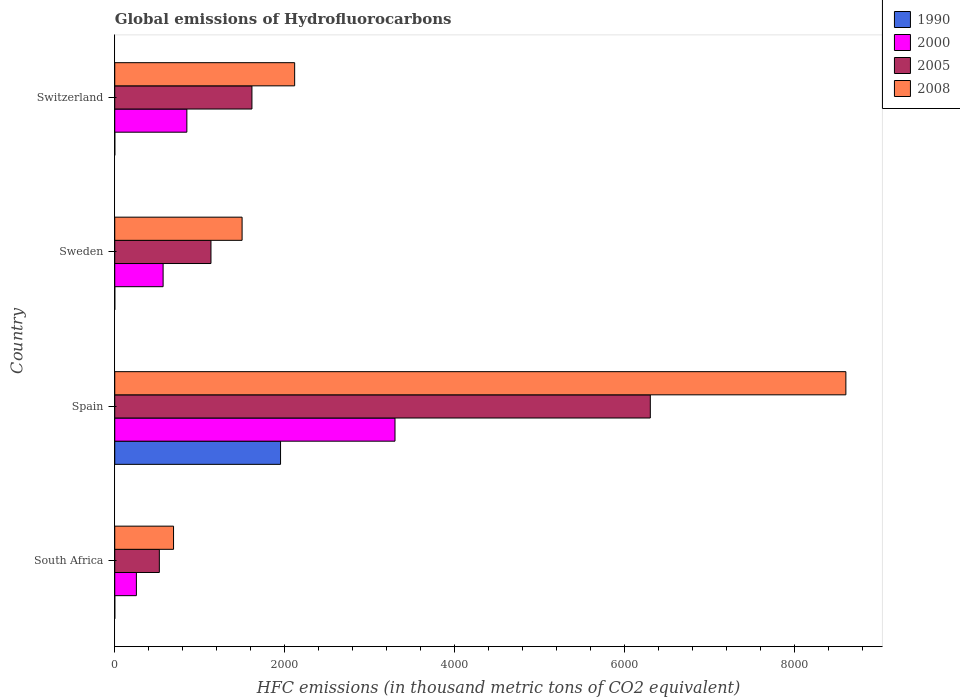Are the number of bars on each tick of the Y-axis equal?
Keep it short and to the point. Yes. How many bars are there on the 2nd tick from the bottom?
Keep it short and to the point. 4. What is the label of the 2nd group of bars from the top?
Make the answer very short. Sweden. In how many cases, is the number of bars for a given country not equal to the number of legend labels?
Offer a terse response. 0. What is the global emissions of Hydrofluorocarbons in 2000 in Spain?
Provide a short and direct response. 3296.8. Across all countries, what is the maximum global emissions of Hydrofluorocarbons in 2000?
Provide a short and direct response. 3296.8. Across all countries, what is the minimum global emissions of Hydrofluorocarbons in 2008?
Your answer should be very brief. 691.6. In which country was the global emissions of Hydrofluorocarbons in 2000 minimum?
Your answer should be very brief. South Africa. What is the total global emissions of Hydrofluorocarbons in 1990 in the graph?
Provide a succinct answer. 1951. What is the difference between the global emissions of Hydrofluorocarbons in 2000 in Spain and that in Sweden?
Make the answer very short. 2728. What is the difference between the global emissions of Hydrofluorocarbons in 2005 in Switzerland and the global emissions of Hydrofluorocarbons in 1990 in Spain?
Keep it short and to the point. -336.5. What is the average global emissions of Hydrofluorocarbons in 1990 per country?
Make the answer very short. 487.75. What is the difference between the global emissions of Hydrofluorocarbons in 2008 and global emissions of Hydrofluorocarbons in 1990 in Spain?
Provide a succinct answer. 6650.6. In how many countries, is the global emissions of Hydrofluorocarbons in 1990 greater than 2000 thousand metric tons?
Ensure brevity in your answer.  0. What is the ratio of the global emissions of Hydrofluorocarbons in 2008 in Spain to that in Sweden?
Give a very brief answer. 5.74. Is the global emissions of Hydrofluorocarbons in 2000 in Spain less than that in Sweden?
Provide a short and direct response. No. Is the difference between the global emissions of Hydrofluorocarbons in 2008 in Spain and Switzerland greater than the difference between the global emissions of Hydrofluorocarbons in 1990 in Spain and Switzerland?
Your answer should be very brief. Yes. What is the difference between the highest and the second highest global emissions of Hydrofluorocarbons in 2000?
Give a very brief answer. 2448.6. What is the difference between the highest and the lowest global emissions of Hydrofluorocarbons in 2000?
Ensure brevity in your answer.  3042.2. Is the sum of the global emissions of Hydrofluorocarbons in 2008 in South Africa and Spain greater than the maximum global emissions of Hydrofluorocarbons in 1990 across all countries?
Offer a very short reply. Yes. Is it the case that in every country, the sum of the global emissions of Hydrofluorocarbons in 2000 and global emissions of Hydrofluorocarbons in 1990 is greater than the sum of global emissions of Hydrofluorocarbons in 2005 and global emissions of Hydrofluorocarbons in 2008?
Ensure brevity in your answer.  No. What does the 1st bar from the bottom in Sweden represents?
Your answer should be compact. 1990. Is it the case that in every country, the sum of the global emissions of Hydrofluorocarbons in 1990 and global emissions of Hydrofluorocarbons in 2008 is greater than the global emissions of Hydrofluorocarbons in 2005?
Keep it short and to the point. Yes. What is the difference between two consecutive major ticks on the X-axis?
Ensure brevity in your answer.  2000. Does the graph contain any zero values?
Keep it short and to the point. No. Does the graph contain grids?
Your answer should be compact. No. How many legend labels are there?
Your response must be concise. 4. How are the legend labels stacked?
Your response must be concise. Vertical. What is the title of the graph?
Offer a terse response. Global emissions of Hydrofluorocarbons. What is the label or title of the X-axis?
Make the answer very short. HFC emissions (in thousand metric tons of CO2 equivalent). What is the HFC emissions (in thousand metric tons of CO2 equivalent) in 2000 in South Africa?
Provide a succinct answer. 254.6. What is the HFC emissions (in thousand metric tons of CO2 equivalent) of 2005 in South Africa?
Offer a very short reply. 524.5. What is the HFC emissions (in thousand metric tons of CO2 equivalent) in 2008 in South Africa?
Provide a short and direct response. 691.6. What is the HFC emissions (in thousand metric tons of CO2 equivalent) of 1990 in Spain?
Give a very brief answer. 1950.3. What is the HFC emissions (in thousand metric tons of CO2 equivalent) of 2000 in Spain?
Provide a succinct answer. 3296.8. What is the HFC emissions (in thousand metric tons of CO2 equivalent) in 2005 in Spain?
Provide a short and direct response. 6300.3. What is the HFC emissions (in thousand metric tons of CO2 equivalent) in 2008 in Spain?
Ensure brevity in your answer.  8600.9. What is the HFC emissions (in thousand metric tons of CO2 equivalent) of 1990 in Sweden?
Your response must be concise. 0.2. What is the HFC emissions (in thousand metric tons of CO2 equivalent) of 2000 in Sweden?
Give a very brief answer. 568.8. What is the HFC emissions (in thousand metric tons of CO2 equivalent) of 2005 in Sweden?
Your answer should be compact. 1131.9. What is the HFC emissions (in thousand metric tons of CO2 equivalent) in 2008 in Sweden?
Your answer should be very brief. 1498. What is the HFC emissions (in thousand metric tons of CO2 equivalent) of 2000 in Switzerland?
Ensure brevity in your answer.  848.2. What is the HFC emissions (in thousand metric tons of CO2 equivalent) in 2005 in Switzerland?
Your response must be concise. 1613.8. What is the HFC emissions (in thousand metric tons of CO2 equivalent) in 2008 in Switzerland?
Keep it short and to the point. 2116.4. Across all countries, what is the maximum HFC emissions (in thousand metric tons of CO2 equivalent) in 1990?
Your answer should be very brief. 1950.3. Across all countries, what is the maximum HFC emissions (in thousand metric tons of CO2 equivalent) of 2000?
Provide a succinct answer. 3296.8. Across all countries, what is the maximum HFC emissions (in thousand metric tons of CO2 equivalent) of 2005?
Give a very brief answer. 6300.3. Across all countries, what is the maximum HFC emissions (in thousand metric tons of CO2 equivalent) in 2008?
Your answer should be very brief. 8600.9. Across all countries, what is the minimum HFC emissions (in thousand metric tons of CO2 equivalent) of 1990?
Make the answer very short. 0.2. Across all countries, what is the minimum HFC emissions (in thousand metric tons of CO2 equivalent) in 2000?
Offer a very short reply. 254.6. Across all countries, what is the minimum HFC emissions (in thousand metric tons of CO2 equivalent) in 2005?
Offer a terse response. 524.5. Across all countries, what is the minimum HFC emissions (in thousand metric tons of CO2 equivalent) in 2008?
Your answer should be compact. 691.6. What is the total HFC emissions (in thousand metric tons of CO2 equivalent) in 1990 in the graph?
Provide a short and direct response. 1951. What is the total HFC emissions (in thousand metric tons of CO2 equivalent) in 2000 in the graph?
Your answer should be compact. 4968.4. What is the total HFC emissions (in thousand metric tons of CO2 equivalent) in 2005 in the graph?
Provide a short and direct response. 9570.5. What is the total HFC emissions (in thousand metric tons of CO2 equivalent) of 2008 in the graph?
Your response must be concise. 1.29e+04. What is the difference between the HFC emissions (in thousand metric tons of CO2 equivalent) of 1990 in South Africa and that in Spain?
Give a very brief answer. -1950.1. What is the difference between the HFC emissions (in thousand metric tons of CO2 equivalent) in 2000 in South Africa and that in Spain?
Your answer should be compact. -3042.2. What is the difference between the HFC emissions (in thousand metric tons of CO2 equivalent) in 2005 in South Africa and that in Spain?
Offer a terse response. -5775.8. What is the difference between the HFC emissions (in thousand metric tons of CO2 equivalent) of 2008 in South Africa and that in Spain?
Give a very brief answer. -7909.3. What is the difference between the HFC emissions (in thousand metric tons of CO2 equivalent) of 2000 in South Africa and that in Sweden?
Offer a terse response. -314.2. What is the difference between the HFC emissions (in thousand metric tons of CO2 equivalent) in 2005 in South Africa and that in Sweden?
Make the answer very short. -607.4. What is the difference between the HFC emissions (in thousand metric tons of CO2 equivalent) in 2008 in South Africa and that in Sweden?
Your answer should be very brief. -806.4. What is the difference between the HFC emissions (in thousand metric tons of CO2 equivalent) of 1990 in South Africa and that in Switzerland?
Offer a terse response. -0.1. What is the difference between the HFC emissions (in thousand metric tons of CO2 equivalent) in 2000 in South Africa and that in Switzerland?
Make the answer very short. -593.6. What is the difference between the HFC emissions (in thousand metric tons of CO2 equivalent) of 2005 in South Africa and that in Switzerland?
Your answer should be very brief. -1089.3. What is the difference between the HFC emissions (in thousand metric tons of CO2 equivalent) of 2008 in South Africa and that in Switzerland?
Your response must be concise. -1424.8. What is the difference between the HFC emissions (in thousand metric tons of CO2 equivalent) in 1990 in Spain and that in Sweden?
Ensure brevity in your answer.  1950.1. What is the difference between the HFC emissions (in thousand metric tons of CO2 equivalent) in 2000 in Spain and that in Sweden?
Offer a very short reply. 2728. What is the difference between the HFC emissions (in thousand metric tons of CO2 equivalent) in 2005 in Spain and that in Sweden?
Your answer should be very brief. 5168.4. What is the difference between the HFC emissions (in thousand metric tons of CO2 equivalent) in 2008 in Spain and that in Sweden?
Give a very brief answer. 7102.9. What is the difference between the HFC emissions (in thousand metric tons of CO2 equivalent) in 1990 in Spain and that in Switzerland?
Provide a short and direct response. 1950. What is the difference between the HFC emissions (in thousand metric tons of CO2 equivalent) in 2000 in Spain and that in Switzerland?
Ensure brevity in your answer.  2448.6. What is the difference between the HFC emissions (in thousand metric tons of CO2 equivalent) of 2005 in Spain and that in Switzerland?
Your response must be concise. 4686.5. What is the difference between the HFC emissions (in thousand metric tons of CO2 equivalent) in 2008 in Spain and that in Switzerland?
Keep it short and to the point. 6484.5. What is the difference between the HFC emissions (in thousand metric tons of CO2 equivalent) in 1990 in Sweden and that in Switzerland?
Offer a very short reply. -0.1. What is the difference between the HFC emissions (in thousand metric tons of CO2 equivalent) in 2000 in Sweden and that in Switzerland?
Provide a succinct answer. -279.4. What is the difference between the HFC emissions (in thousand metric tons of CO2 equivalent) in 2005 in Sweden and that in Switzerland?
Give a very brief answer. -481.9. What is the difference between the HFC emissions (in thousand metric tons of CO2 equivalent) of 2008 in Sweden and that in Switzerland?
Offer a very short reply. -618.4. What is the difference between the HFC emissions (in thousand metric tons of CO2 equivalent) in 1990 in South Africa and the HFC emissions (in thousand metric tons of CO2 equivalent) in 2000 in Spain?
Provide a succinct answer. -3296.6. What is the difference between the HFC emissions (in thousand metric tons of CO2 equivalent) in 1990 in South Africa and the HFC emissions (in thousand metric tons of CO2 equivalent) in 2005 in Spain?
Provide a short and direct response. -6300.1. What is the difference between the HFC emissions (in thousand metric tons of CO2 equivalent) in 1990 in South Africa and the HFC emissions (in thousand metric tons of CO2 equivalent) in 2008 in Spain?
Your answer should be very brief. -8600.7. What is the difference between the HFC emissions (in thousand metric tons of CO2 equivalent) of 2000 in South Africa and the HFC emissions (in thousand metric tons of CO2 equivalent) of 2005 in Spain?
Offer a terse response. -6045.7. What is the difference between the HFC emissions (in thousand metric tons of CO2 equivalent) of 2000 in South Africa and the HFC emissions (in thousand metric tons of CO2 equivalent) of 2008 in Spain?
Offer a terse response. -8346.3. What is the difference between the HFC emissions (in thousand metric tons of CO2 equivalent) in 2005 in South Africa and the HFC emissions (in thousand metric tons of CO2 equivalent) in 2008 in Spain?
Ensure brevity in your answer.  -8076.4. What is the difference between the HFC emissions (in thousand metric tons of CO2 equivalent) of 1990 in South Africa and the HFC emissions (in thousand metric tons of CO2 equivalent) of 2000 in Sweden?
Provide a succinct answer. -568.6. What is the difference between the HFC emissions (in thousand metric tons of CO2 equivalent) of 1990 in South Africa and the HFC emissions (in thousand metric tons of CO2 equivalent) of 2005 in Sweden?
Give a very brief answer. -1131.7. What is the difference between the HFC emissions (in thousand metric tons of CO2 equivalent) in 1990 in South Africa and the HFC emissions (in thousand metric tons of CO2 equivalent) in 2008 in Sweden?
Keep it short and to the point. -1497.8. What is the difference between the HFC emissions (in thousand metric tons of CO2 equivalent) in 2000 in South Africa and the HFC emissions (in thousand metric tons of CO2 equivalent) in 2005 in Sweden?
Your response must be concise. -877.3. What is the difference between the HFC emissions (in thousand metric tons of CO2 equivalent) of 2000 in South Africa and the HFC emissions (in thousand metric tons of CO2 equivalent) of 2008 in Sweden?
Ensure brevity in your answer.  -1243.4. What is the difference between the HFC emissions (in thousand metric tons of CO2 equivalent) in 2005 in South Africa and the HFC emissions (in thousand metric tons of CO2 equivalent) in 2008 in Sweden?
Your response must be concise. -973.5. What is the difference between the HFC emissions (in thousand metric tons of CO2 equivalent) of 1990 in South Africa and the HFC emissions (in thousand metric tons of CO2 equivalent) of 2000 in Switzerland?
Provide a short and direct response. -848. What is the difference between the HFC emissions (in thousand metric tons of CO2 equivalent) of 1990 in South Africa and the HFC emissions (in thousand metric tons of CO2 equivalent) of 2005 in Switzerland?
Your answer should be compact. -1613.6. What is the difference between the HFC emissions (in thousand metric tons of CO2 equivalent) of 1990 in South Africa and the HFC emissions (in thousand metric tons of CO2 equivalent) of 2008 in Switzerland?
Your answer should be compact. -2116.2. What is the difference between the HFC emissions (in thousand metric tons of CO2 equivalent) in 2000 in South Africa and the HFC emissions (in thousand metric tons of CO2 equivalent) in 2005 in Switzerland?
Offer a very short reply. -1359.2. What is the difference between the HFC emissions (in thousand metric tons of CO2 equivalent) in 2000 in South Africa and the HFC emissions (in thousand metric tons of CO2 equivalent) in 2008 in Switzerland?
Offer a terse response. -1861.8. What is the difference between the HFC emissions (in thousand metric tons of CO2 equivalent) in 2005 in South Africa and the HFC emissions (in thousand metric tons of CO2 equivalent) in 2008 in Switzerland?
Your response must be concise. -1591.9. What is the difference between the HFC emissions (in thousand metric tons of CO2 equivalent) of 1990 in Spain and the HFC emissions (in thousand metric tons of CO2 equivalent) of 2000 in Sweden?
Keep it short and to the point. 1381.5. What is the difference between the HFC emissions (in thousand metric tons of CO2 equivalent) of 1990 in Spain and the HFC emissions (in thousand metric tons of CO2 equivalent) of 2005 in Sweden?
Make the answer very short. 818.4. What is the difference between the HFC emissions (in thousand metric tons of CO2 equivalent) in 1990 in Spain and the HFC emissions (in thousand metric tons of CO2 equivalent) in 2008 in Sweden?
Offer a terse response. 452.3. What is the difference between the HFC emissions (in thousand metric tons of CO2 equivalent) in 2000 in Spain and the HFC emissions (in thousand metric tons of CO2 equivalent) in 2005 in Sweden?
Offer a terse response. 2164.9. What is the difference between the HFC emissions (in thousand metric tons of CO2 equivalent) in 2000 in Spain and the HFC emissions (in thousand metric tons of CO2 equivalent) in 2008 in Sweden?
Make the answer very short. 1798.8. What is the difference between the HFC emissions (in thousand metric tons of CO2 equivalent) in 2005 in Spain and the HFC emissions (in thousand metric tons of CO2 equivalent) in 2008 in Sweden?
Provide a short and direct response. 4802.3. What is the difference between the HFC emissions (in thousand metric tons of CO2 equivalent) of 1990 in Spain and the HFC emissions (in thousand metric tons of CO2 equivalent) of 2000 in Switzerland?
Give a very brief answer. 1102.1. What is the difference between the HFC emissions (in thousand metric tons of CO2 equivalent) in 1990 in Spain and the HFC emissions (in thousand metric tons of CO2 equivalent) in 2005 in Switzerland?
Provide a short and direct response. 336.5. What is the difference between the HFC emissions (in thousand metric tons of CO2 equivalent) of 1990 in Spain and the HFC emissions (in thousand metric tons of CO2 equivalent) of 2008 in Switzerland?
Provide a short and direct response. -166.1. What is the difference between the HFC emissions (in thousand metric tons of CO2 equivalent) of 2000 in Spain and the HFC emissions (in thousand metric tons of CO2 equivalent) of 2005 in Switzerland?
Offer a terse response. 1683. What is the difference between the HFC emissions (in thousand metric tons of CO2 equivalent) of 2000 in Spain and the HFC emissions (in thousand metric tons of CO2 equivalent) of 2008 in Switzerland?
Provide a short and direct response. 1180.4. What is the difference between the HFC emissions (in thousand metric tons of CO2 equivalent) of 2005 in Spain and the HFC emissions (in thousand metric tons of CO2 equivalent) of 2008 in Switzerland?
Offer a very short reply. 4183.9. What is the difference between the HFC emissions (in thousand metric tons of CO2 equivalent) in 1990 in Sweden and the HFC emissions (in thousand metric tons of CO2 equivalent) in 2000 in Switzerland?
Provide a succinct answer. -848. What is the difference between the HFC emissions (in thousand metric tons of CO2 equivalent) in 1990 in Sweden and the HFC emissions (in thousand metric tons of CO2 equivalent) in 2005 in Switzerland?
Offer a terse response. -1613.6. What is the difference between the HFC emissions (in thousand metric tons of CO2 equivalent) of 1990 in Sweden and the HFC emissions (in thousand metric tons of CO2 equivalent) of 2008 in Switzerland?
Give a very brief answer. -2116.2. What is the difference between the HFC emissions (in thousand metric tons of CO2 equivalent) in 2000 in Sweden and the HFC emissions (in thousand metric tons of CO2 equivalent) in 2005 in Switzerland?
Give a very brief answer. -1045. What is the difference between the HFC emissions (in thousand metric tons of CO2 equivalent) of 2000 in Sweden and the HFC emissions (in thousand metric tons of CO2 equivalent) of 2008 in Switzerland?
Offer a very short reply. -1547.6. What is the difference between the HFC emissions (in thousand metric tons of CO2 equivalent) of 2005 in Sweden and the HFC emissions (in thousand metric tons of CO2 equivalent) of 2008 in Switzerland?
Provide a succinct answer. -984.5. What is the average HFC emissions (in thousand metric tons of CO2 equivalent) in 1990 per country?
Provide a succinct answer. 487.75. What is the average HFC emissions (in thousand metric tons of CO2 equivalent) in 2000 per country?
Give a very brief answer. 1242.1. What is the average HFC emissions (in thousand metric tons of CO2 equivalent) in 2005 per country?
Keep it short and to the point. 2392.62. What is the average HFC emissions (in thousand metric tons of CO2 equivalent) of 2008 per country?
Make the answer very short. 3226.72. What is the difference between the HFC emissions (in thousand metric tons of CO2 equivalent) of 1990 and HFC emissions (in thousand metric tons of CO2 equivalent) of 2000 in South Africa?
Offer a terse response. -254.4. What is the difference between the HFC emissions (in thousand metric tons of CO2 equivalent) of 1990 and HFC emissions (in thousand metric tons of CO2 equivalent) of 2005 in South Africa?
Provide a short and direct response. -524.3. What is the difference between the HFC emissions (in thousand metric tons of CO2 equivalent) of 1990 and HFC emissions (in thousand metric tons of CO2 equivalent) of 2008 in South Africa?
Make the answer very short. -691.4. What is the difference between the HFC emissions (in thousand metric tons of CO2 equivalent) of 2000 and HFC emissions (in thousand metric tons of CO2 equivalent) of 2005 in South Africa?
Provide a succinct answer. -269.9. What is the difference between the HFC emissions (in thousand metric tons of CO2 equivalent) in 2000 and HFC emissions (in thousand metric tons of CO2 equivalent) in 2008 in South Africa?
Keep it short and to the point. -437. What is the difference between the HFC emissions (in thousand metric tons of CO2 equivalent) in 2005 and HFC emissions (in thousand metric tons of CO2 equivalent) in 2008 in South Africa?
Provide a succinct answer. -167.1. What is the difference between the HFC emissions (in thousand metric tons of CO2 equivalent) of 1990 and HFC emissions (in thousand metric tons of CO2 equivalent) of 2000 in Spain?
Your response must be concise. -1346.5. What is the difference between the HFC emissions (in thousand metric tons of CO2 equivalent) of 1990 and HFC emissions (in thousand metric tons of CO2 equivalent) of 2005 in Spain?
Your answer should be very brief. -4350. What is the difference between the HFC emissions (in thousand metric tons of CO2 equivalent) in 1990 and HFC emissions (in thousand metric tons of CO2 equivalent) in 2008 in Spain?
Keep it short and to the point. -6650.6. What is the difference between the HFC emissions (in thousand metric tons of CO2 equivalent) of 2000 and HFC emissions (in thousand metric tons of CO2 equivalent) of 2005 in Spain?
Keep it short and to the point. -3003.5. What is the difference between the HFC emissions (in thousand metric tons of CO2 equivalent) in 2000 and HFC emissions (in thousand metric tons of CO2 equivalent) in 2008 in Spain?
Make the answer very short. -5304.1. What is the difference between the HFC emissions (in thousand metric tons of CO2 equivalent) in 2005 and HFC emissions (in thousand metric tons of CO2 equivalent) in 2008 in Spain?
Keep it short and to the point. -2300.6. What is the difference between the HFC emissions (in thousand metric tons of CO2 equivalent) in 1990 and HFC emissions (in thousand metric tons of CO2 equivalent) in 2000 in Sweden?
Your answer should be very brief. -568.6. What is the difference between the HFC emissions (in thousand metric tons of CO2 equivalent) of 1990 and HFC emissions (in thousand metric tons of CO2 equivalent) of 2005 in Sweden?
Offer a terse response. -1131.7. What is the difference between the HFC emissions (in thousand metric tons of CO2 equivalent) of 1990 and HFC emissions (in thousand metric tons of CO2 equivalent) of 2008 in Sweden?
Ensure brevity in your answer.  -1497.8. What is the difference between the HFC emissions (in thousand metric tons of CO2 equivalent) of 2000 and HFC emissions (in thousand metric tons of CO2 equivalent) of 2005 in Sweden?
Make the answer very short. -563.1. What is the difference between the HFC emissions (in thousand metric tons of CO2 equivalent) in 2000 and HFC emissions (in thousand metric tons of CO2 equivalent) in 2008 in Sweden?
Your response must be concise. -929.2. What is the difference between the HFC emissions (in thousand metric tons of CO2 equivalent) of 2005 and HFC emissions (in thousand metric tons of CO2 equivalent) of 2008 in Sweden?
Your answer should be compact. -366.1. What is the difference between the HFC emissions (in thousand metric tons of CO2 equivalent) in 1990 and HFC emissions (in thousand metric tons of CO2 equivalent) in 2000 in Switzerland?
Ensure brevity in your answer.  -847.9. What is the difference between the HFC emissions (in thousand metric tons of CO2 equivalent) in 1990 and HFC emissions (in thousand metric tons of CO2 equivalent) in 2005 in Switzerland?
Your answer should be compact. -1613.5. What is the difference between the HFC emissions (in thousand metric tons of CO2 equivalent) of 1990 and HFC emissions (in thousand metric tons of CO2 equivalent) of 2008 in Switzerland?
Provide a short and direct response. -2116.1. What is the difference between the HFC emissions (in thousand metric tons of CO2 equivalent) of 2000 and HFC emissions (in thousand metric tons of CO2 equivalent) of 2005 in Switzerland?
Your answer should be compact. -765.6. What is the difference between the HFC emissions (in thousand metric tons of CO2 equivalent) in 2000 and HFC emissions (in thousand metric tons of CO2 equivalent) in 2008 in Switzerland?
Give a very brief answer. -1268.2. What is the difference between the HFC emissions (in thousand metric tons of CO2 equivalent) of 2005 and HFC emissions (in thousand metric tons of CO2 equivalent) of 2008 in Switzerland?
Give a very brief answer. -502.6. What is the ratio of the HFC emissions (in thousand metric tons of CO2 equivalent) of 1990 in South Africa to that in Spain?
Give a very brief answer. 0. What is the ratio of the HFC emissions (in thousand metric tons of CO2 equivalent) of 2000 in South Africa to that in Spain?
Offer a very short reply. 0.08. What is the ratio of the HFC emissions (in thousand metric tons of CO2 equivalent) of 2005 in South Africa to that in Spain?
Provide a succinct answer. 0.08. What is the ratio of the HFC emissions (in thousand metric tons of CO2 equivalent) in 2008 in South Africa to that in Spain?
Your answer should be compact. 0.08. What is the ratio of the HFC emissions (in thousand metric tons of CO2 equivalent) in 2000 in South Africa to that in Sweden?
Give a very brief answer. 0.45. What is the ratio of the HFC emissions (in thousand metric tons of CO2 equivalent) in 2005 in South Africa to that in Sweden?
Keep it short and to the point. 0.46. What is the ratio of the HFC emissions (in thousand metric tons of CO2 equivalent) of 2008 in South Africa to that in Sweden?
Give a very brief answer. 0.46. What is the ratio of the HFC emissions (in thousand metric tons of CO2 equivalent) in 1990 in South Africa to that in Switzerland?
Your answer should be very brief. 0.67. What is the ratio of the HFC emissions (in thousand metric tons of CO2 equivalent) in 2000 in South Africa to that in Switzerland?
Your answer should be very brief. 0.3. What is the ratio of the HFC emissions (in thousand metric tons of CO2 equivalent) of 2005 in South Africa to that in Switzerland?
Offer a very short reply. 0.33. What is the ratio of the HFC emissions (in thousand metric tons of CO2 equivalent) in 2008 in South Africa to that in Switzerland?
Provide a short and direct response. 0.33. What is the ratio of the HFC emissions (in thousand metric tons of CO2 equivalent) of 1990 in Spain to that in Sweden?
Make the answer very short. 9751.5. What is the ratio of the HFC emissions (in thousand metric tons of CO2 equivalent) of 2000 in Spain to that in Sweden?
Offer a terse response. 5.8. What is the ratio of the HFC emissions (in thousand metric tons of CO2 equivalent) in 2005 in Spain to that in Sweden?
Provide a short and direct response. 5.57. What is the ratio of the HFC emissions (in thousand metric tons of CO2 equivalent) of 2008 in Spain to that in Sweden?
Your answer should be very brief. 5.74. What is the ratio of the HFC emissions (in thousand metric tons of CO2 equivalent) of 1990 in Spain to that in Switzerland?
Offer a terse response. 6501. What is the ratio of the HFC emissions (in thousand metric tons of CO2 equivalent) in 2000 in Spain to that in Switzerland?
Give a very brief answer. 3.89. What is the ratio of the HFC emissions (in thousand metric tons of CO2 equivalent) of 2005 in Spain to that in Switzerland?
Keep it short and to the point. 3.9. What is the ratio of the HFC emissions (in thousand metric tons of CO2 equivalent) of 2008 in Spain to that in Switzerland?
Your answer should be compact. 4.06. What is the ratio of the HFC emissions (in thousand metric tons of CO2 equivalent) in 1990 in Sweden to that in Switzerland?
Offer a very short reply. 0.67. What is the ratio of the HFC emissions (in thousand metric tons of CO2 equivalent) in 2000 in Sweden to that in Switzerland?
Make the answer very short. 0.67. What is the ratio of the HFC emissions (in thousand metric tons of CO2 equivalent) of 2005 in Sweden to that in Switzerland?
Your answer should be compact. 0.7. What is the ratio of the HFC emissions (in thousand metric tons of CO2 equivalent) of 2008 in Sweden to that in Switzerland?
Your answer should be very brief. 0.71. What is the difference between the highest and the second highest HFC emissions (in thousand metric tons of CO2 equivalent) in 1990?
Your response must be concise. 1950. What is the difference between the highest and the second highest HFC emissions (in thousand metric tons of CO2 equivalent) of 2000?
Provide a succinct answer. 2448.6. What is the difference between the highest and the second highest HFC emissions (in thousand metric tons of CO2 equivalent) in 2005?
Ensure brevity in your answer.  4686.5. What is the difference between the highest and the second highest HFC emissions (in thousand metric tons of CO2 equivalent) in 2008?
Ensure brevity in your answer.  6484.5. What is the difference between the highest and the lowest HFC emissions (in thousand metric tons of CO2 equivalent) of 1990?
Give a very brief answer. 1950.1. What is the difference between the highest and the lowest HFC emissions (in thousand metric tons of CO2 equivalent) in 2000?
Your answer should be very brief. 3042.2. What is the difference between the highest and the lowest HFC emissions (in thousand metric tons of CO2 equivalent) of 2005?
Give a very brief answer. 5775.8. What is the difference between the highest and the lowest HFC emissions (in thousand metric tons of CO2 equivalent) in 2008?
Make the answer very short. 7909.3. 